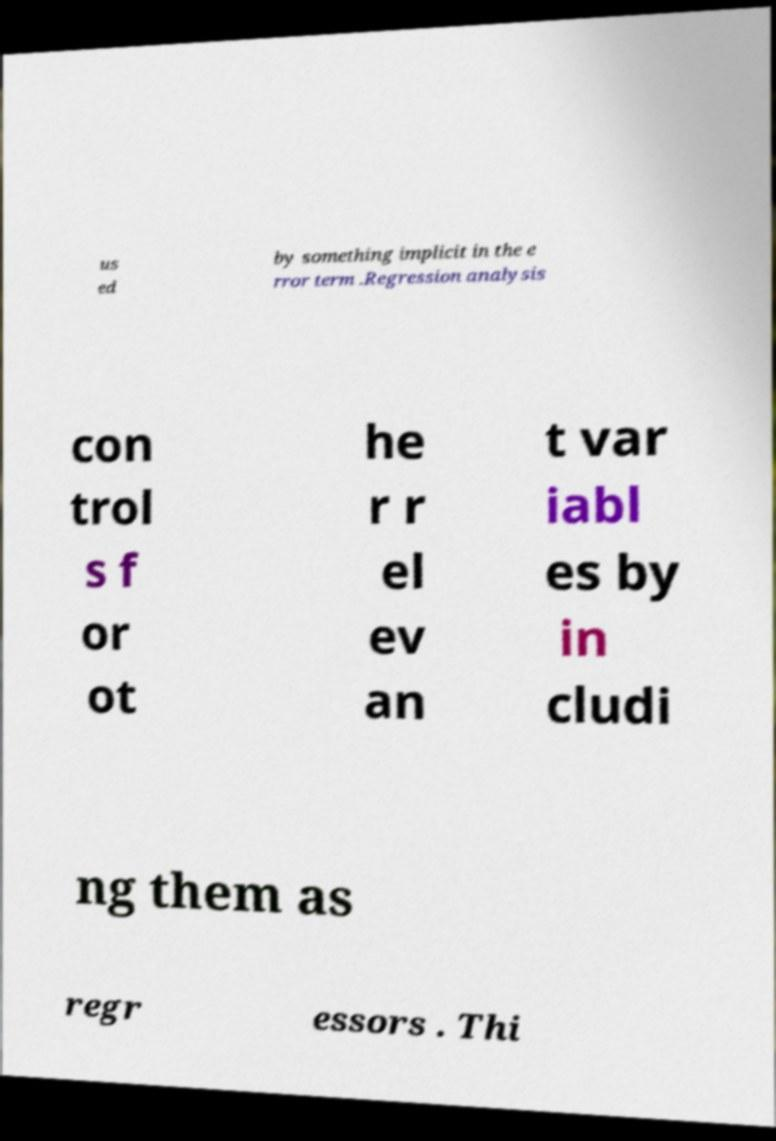I need the written content from this picture converted into text. Can you do that? us ed by something implicit in the e rror term .Regression analysis con trol s f or ot he r r el ev an t var iabl es by in cludi ng them as regr essors . Thi 